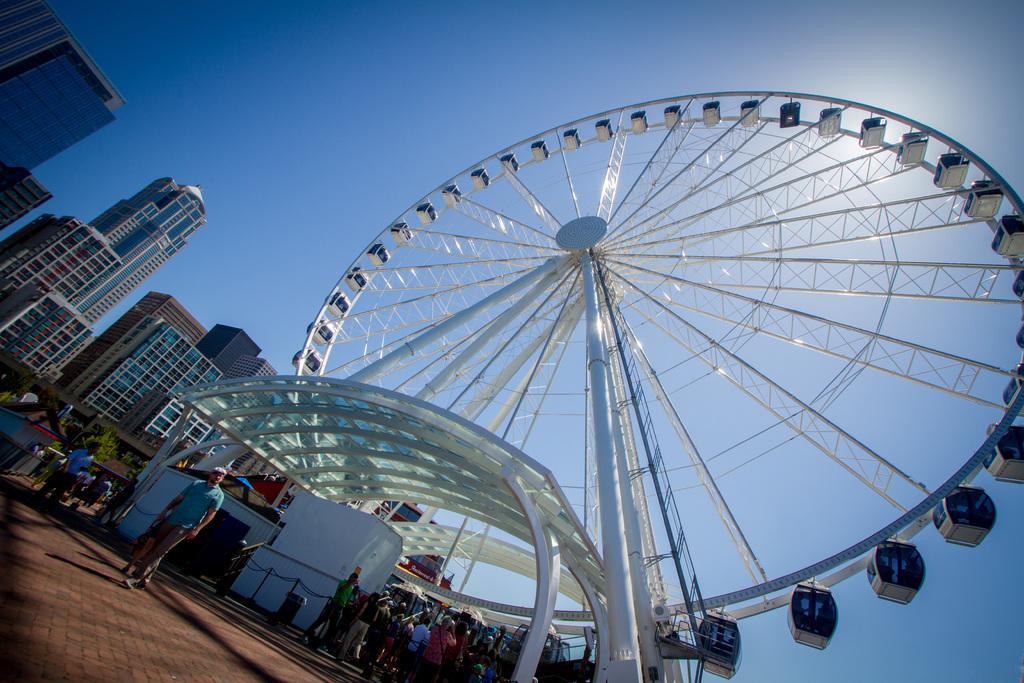Could you give a brief overview of what you see in this image? In this image there are people standing on the road. There is a glass rooftop supported by metal rods. There is a dustbin. There is a metal fence. There is a giant wheel. In the background of the image there are trees, buildings and sky. 